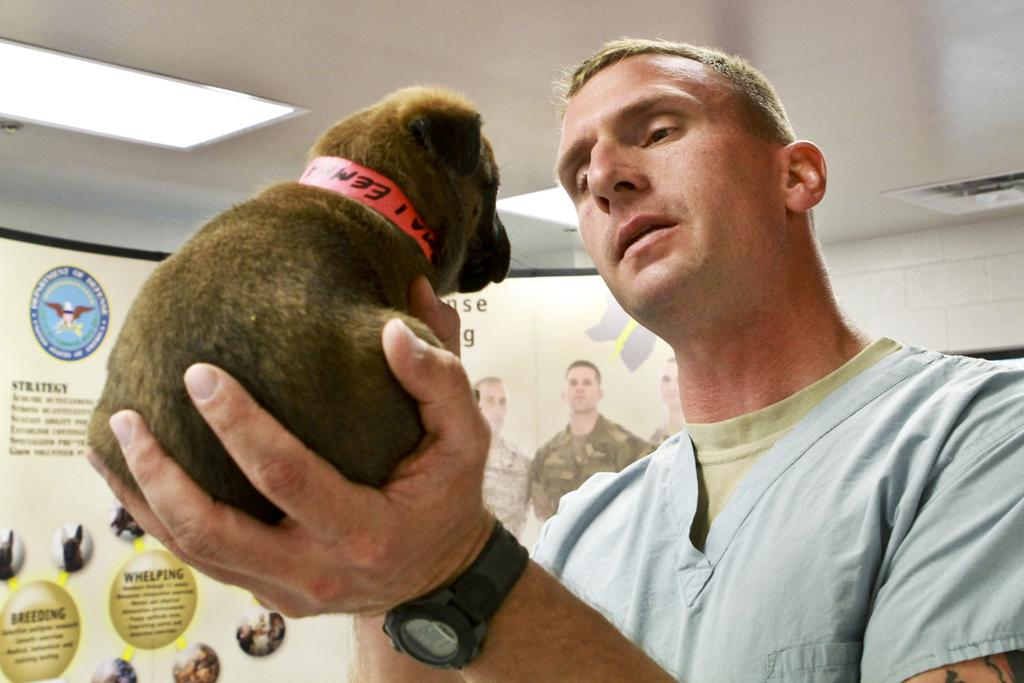Who or what is the main subject of the image? There is a person in the image. What is the person wearing? The person is wearing a blue shirt. What is the person holding in their hand? The person is holding a puppy in their left hand. How many books can be seen on the person's finger in the image? There are no books visible in the image, and the person's fingers are not mentioned in the provided facts. 